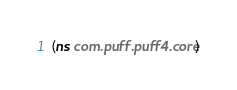<code> <loc_0><loc_0><loc_500><loc_500><_Clojure_>(ns com.puff.puff4.core)
</code> 